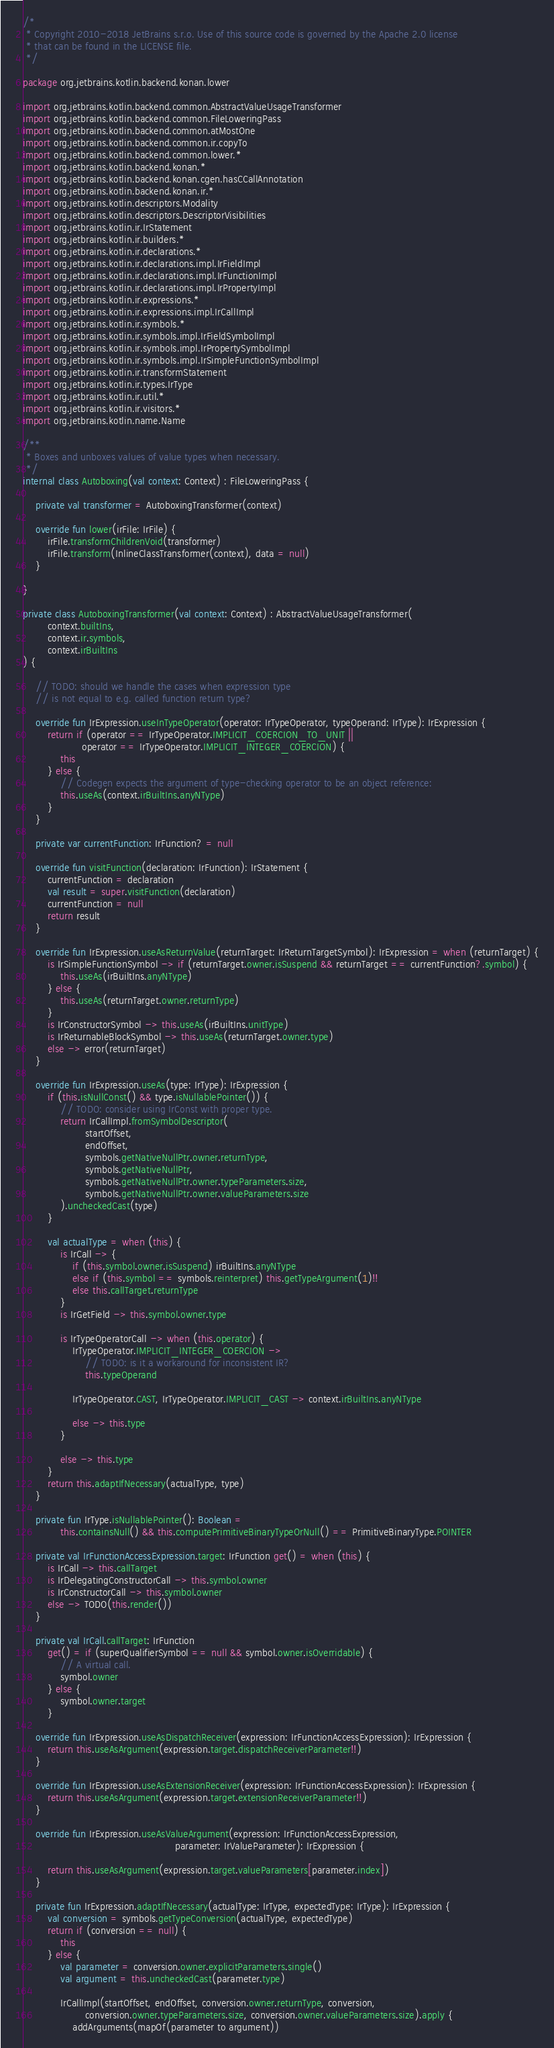Convert code to text. <code><loc_0><loc_0><loc_500><loc_500><_Kotlin_>/*
 * Copyright 2010-2018 JetBrains s.r.o. Use of this source code is governed by the Apache 2.0 license
 * that can be found in the LICENSE file.
 */

package org.jetbrains.kotlin.backend.konan.lower

import org.jetbrains.kotlin.backend.common.AbstractValueUsageTransformer
import org.jetbrains.kotlin.backend.common.FileLoweringPass
import org.jetbrains.kotlin.backend.common.atMostOne
import org.jetbrains.kotlin.backend.common.ir.copyTo
import org.jetbrains.kotlin.backend.common.lower.*
import org.jetbrains.kotlin.backend.konan.*
import org.jetbrains.kotlin.backend.konan.cgen.hasCCallAnnotation
import org.jetbrains.kotlin.backend.konan.ir.*
import org.jetbrains.kotlin.descriptors.Modality
import org.jetbrains.kotlin.descriptors.DescriptorVisibilities
import org.jetbrains.kotlin.ir.IrStatement
import org.jetbrains.kotlin.ir.builders.*
import org.jetbrains.kotlin.ir.declarations.*
import org.jetbrains.kotlin.ir.declarations.impl.IrFieldImpl
import org.jetbrains.kotlin.ir.declarations.impl.IrFunctionImpl
import org.jetbrains.kotlin.ir.declarations.impl.IrPropertyImpl
import org.jetbrains.kotlin.ir.expressions.*
import org.jetbrains.kotlin.ir.expressions.impl.IrCallImpl
import org.jetbrains.kotlin.ir.symbols.*
import org.jetbrains.kotlin.ir.symbols.impl.IrFieldSymbolImpl
import org.jetbrains.kotlin.ir.symbols.impl.IrPropertySymbolImpl
import org.jetbrains.kotlin.ir.symbols.impl.IrSimpleFunctionSymbolImpl
import org.jetbrains.kotlin.ir.transformStatement
import org.jetbrains.kotlin.ir.types.IrType
import org.jetbrains.kotlin.ir.util.*
import org.jetbrains.kotlin.ir.visitors.*
import org.jetbrains.kotlin.name.Name

/**
 * Boxes and unboxes values of value types when necessary.
 */
internal class Autoboxing(val context: Context) : FileLoweringPass {

    private val transformer = AutoboxingTransformer(context)

    override fun lower(irFile: IrFile) {
        irFile.transformChildrenVoid(transformer)
        irFile.transform(InlineClassTransformer(context), data = null)
    }

}

private class AutoboxingTransformer(val context: Context) : AbstractValueUsageTransformer(
        context.builtIns,
        context.ir.symbols,
        context.irBuiltIns
) {

    // TODO: should we handle the cases when expression type
    // is not equal to e.g. called function return type?

    override fun IrExpression.useInTypeOperator(operator: IrTypeOperator, typeOperand: IrType): IrExpression {
        return if (operator == IrTypeOperator.IMPLICIT_COERCION_TO_UNIT ||
                   operator == IrTypeOperator.IMPLICIT_INTEGER_COERCION) {
            this
        } else {
            // Codegen expects the argument of type-checking operator to be an object reference:
            this.useAs(context.irBuiltIns.anyNType)
        }
    }

    private var currentFunction: IrFunction? = null

    override fun visitFunction(declaration: IrFunction): IrStatement {
        currentFunction = declaration
        val result = super.visitFunction(declaration)
        currentFunction = null
        return result
    }

    override fun IrExpression.useAsReturnValue(returnTarget: IrReturnTargetSymbol): IrExpression = when (returnTarget) {
        is IrSimpleFunctionSymbol -> if (returnTarget.owner.isSuspend && returnTarget == currentFunction?.symbol) {
            this.useAs(irBuiltIns.anyNType)
        } else {
            this.useAs(returnTarget.owner.returnType)
        }
        is IrConstructorSymbol -> this.useAs(irBuiltIns.unitType)
        is IrReturnableBlockSymbol -> this.useAs(returnTarget.owner.type)
        else -> error(returnTarget)
    }

    override fun IrExpression.useAs(type: IrType): IrExpression {
        if (this.isNullConst() && type.isNullablePointer()) {
            // TODO: consider using IrConst with proper type.
            return IrCallImpl.fromSymbolDescriptor(
                    startOffset,
                    endOffset,
                    symbols.getNativeNullPtr.owner.returnType,
                    symbols.getNativeNullPtr,
                    symbols.getNativeNullPtr.owner.typeParameters.size,
                    symbols.getNativeNullPtr.owner.valueParameters.size
            ).uncheckedCast(type)
        }

        val actualType = when (this) {
            is IrCall -> {
                if (this.symbol.owner.isSuspend) irBuiltIns.anyNType
                else if (this.symbol == symbols.reinterpret) this.getTypeArgument(1)!!
                else this.callTarget.returnType
            }
            is IrGetField -> this.symbol.owner.type

            is IrTypeOperatorCall -> when (this.operator) {
                IrTypeOperator.IMPLICIT_INTEGER_COERCION ->
                    // TODO: is it a workaround for inconsistent IR?
                    this.typeOperand

                IrTypeOperator.CAST, IrTypeOperator.IMPLICIT_CAST -> context.irBuiltIns.anyNType

                else -> this.type
            }

            else -> this.type
        }
        return this.adaptIfNecessary(actualType, type)
    }

    private fun IrType.isNullablePointer(): Boolean =
            this.containsNull() && this.computePrimitiveBinaryTypeOrNull() == PrimitiveBinaryType.POINTER

    private val IrFunctionAccessExpression.target: IrFunction get() = when (this) {
        is IrCall -> this.callTarget
        is IrDelegatingConstructorCall -> this.symbol.owner
        is IrConstructorCall -> this.symbol.owner
        else -> TODO(this.render())
    }

    private val IrCall.callTarget: IrFunction
        get() = if (superQualifierSymbol == null && symbol.owner.isOverridable) {
            // A virtual call.
            symbol.owner
        } else {
            symbol.owner.target
        }

    override fun IrExpression.useAsDispatchReceiver(expression: IrFunctionAccessExpression): IrExpression {
        return this.useAsArgument(expression.target.dispatchReceiverParameter!!)
    }

    override fun IrExpression.useAsExtensionReceiver(expression: IrFunctionAccessExpression): IrExpression {
        return this.useAsArgument(expression.target.extensionReceiverParameter!!)
    }

    override fun IrExpression.useAsValueArgument(expression: IrFunctionAccessExpression,
                                                 parameter: IrValueParameter): IrExpression {

        return this.useAsArgument(expression.target.valueParameters[parameter.index])
    }

    private fun IrExpression.adaptIfNecessary(actualType: IrType, expectedType: IrType): IrExpression {
        val conversion = symbols.getTypeConversion(actualType, expectedType)
        return if (conversion == null) {
            this
        } else {
            val parameter = conversion.owner.explicitParameters.single()
            val argument = this.uncheckedCast(parameter.type)

            IrCallImpl(startOffset, endOffset, conversion.owner.returnType, conversion,
                    conversion.owner.typeParameters.size, conversion.owner.valueParameters.size).apply {
                addArguments(mapOf(parameter to argument))</code> 